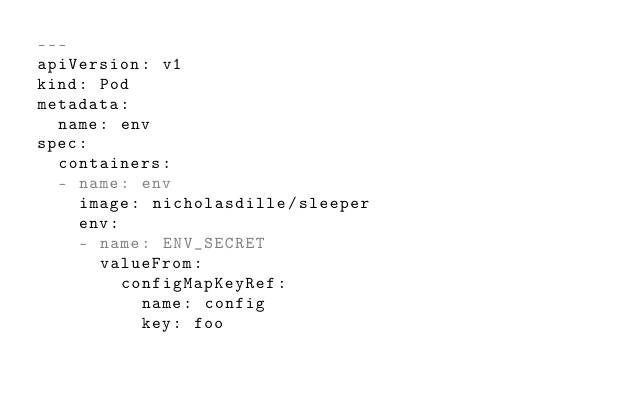Convert code to text. <code><loc_0><loc_0><loc_500><loc_500><_YAML_>---
apiVersion: v1
kind: Pod
metadata:
  name: env
spec:
  containers:
  - name: env
    image: nicholasdille/sleeper
    env:
    - name: ENV_SECRET
      valueFrom:
        configMapKeyRef:
          name: config
          key: foo
</code> 